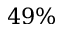<formula> <loc_0><loc_0><loc_500><loc_500>4 9 \%</formula> 